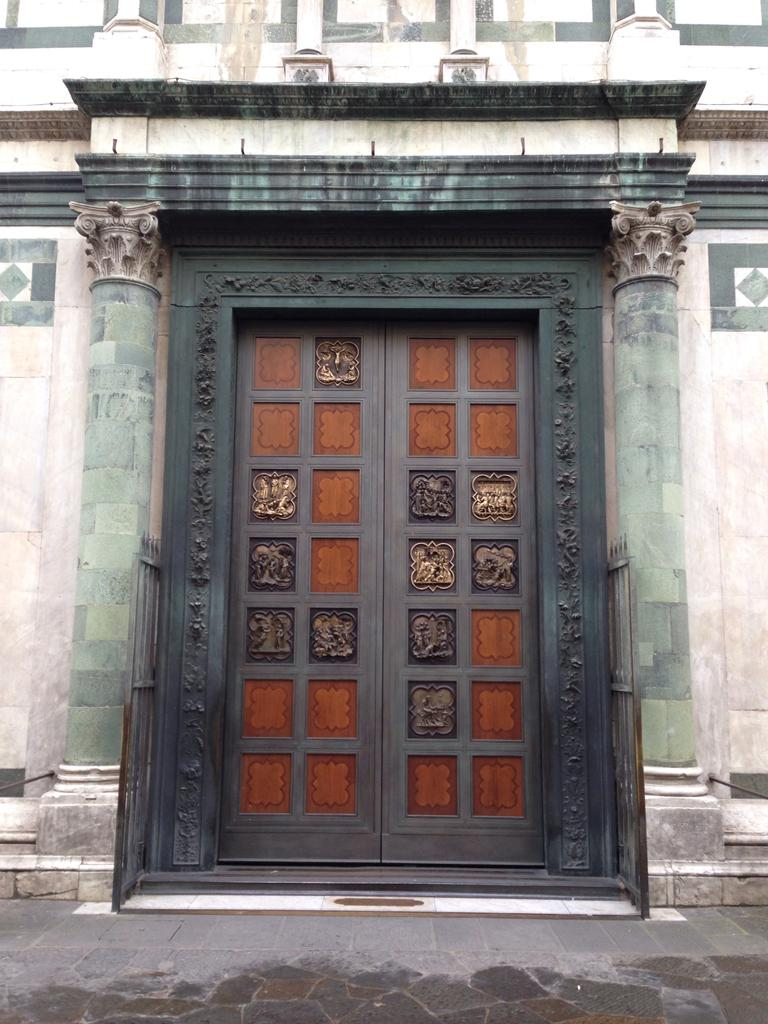What is the main object in the image? There is a door in the image. How is the door connected to the surrounding structure? The door is attached to a wall. What is visible in front of the door? There is a pavement in front of the door. What decorative elements are present on the door? There are sculptures on the door. What is the aftermath of the rainstorm in the image? There is no rainstorm or aftermath present in the image; it only features a door, a wall, a pavement, and sculptures on the door. 